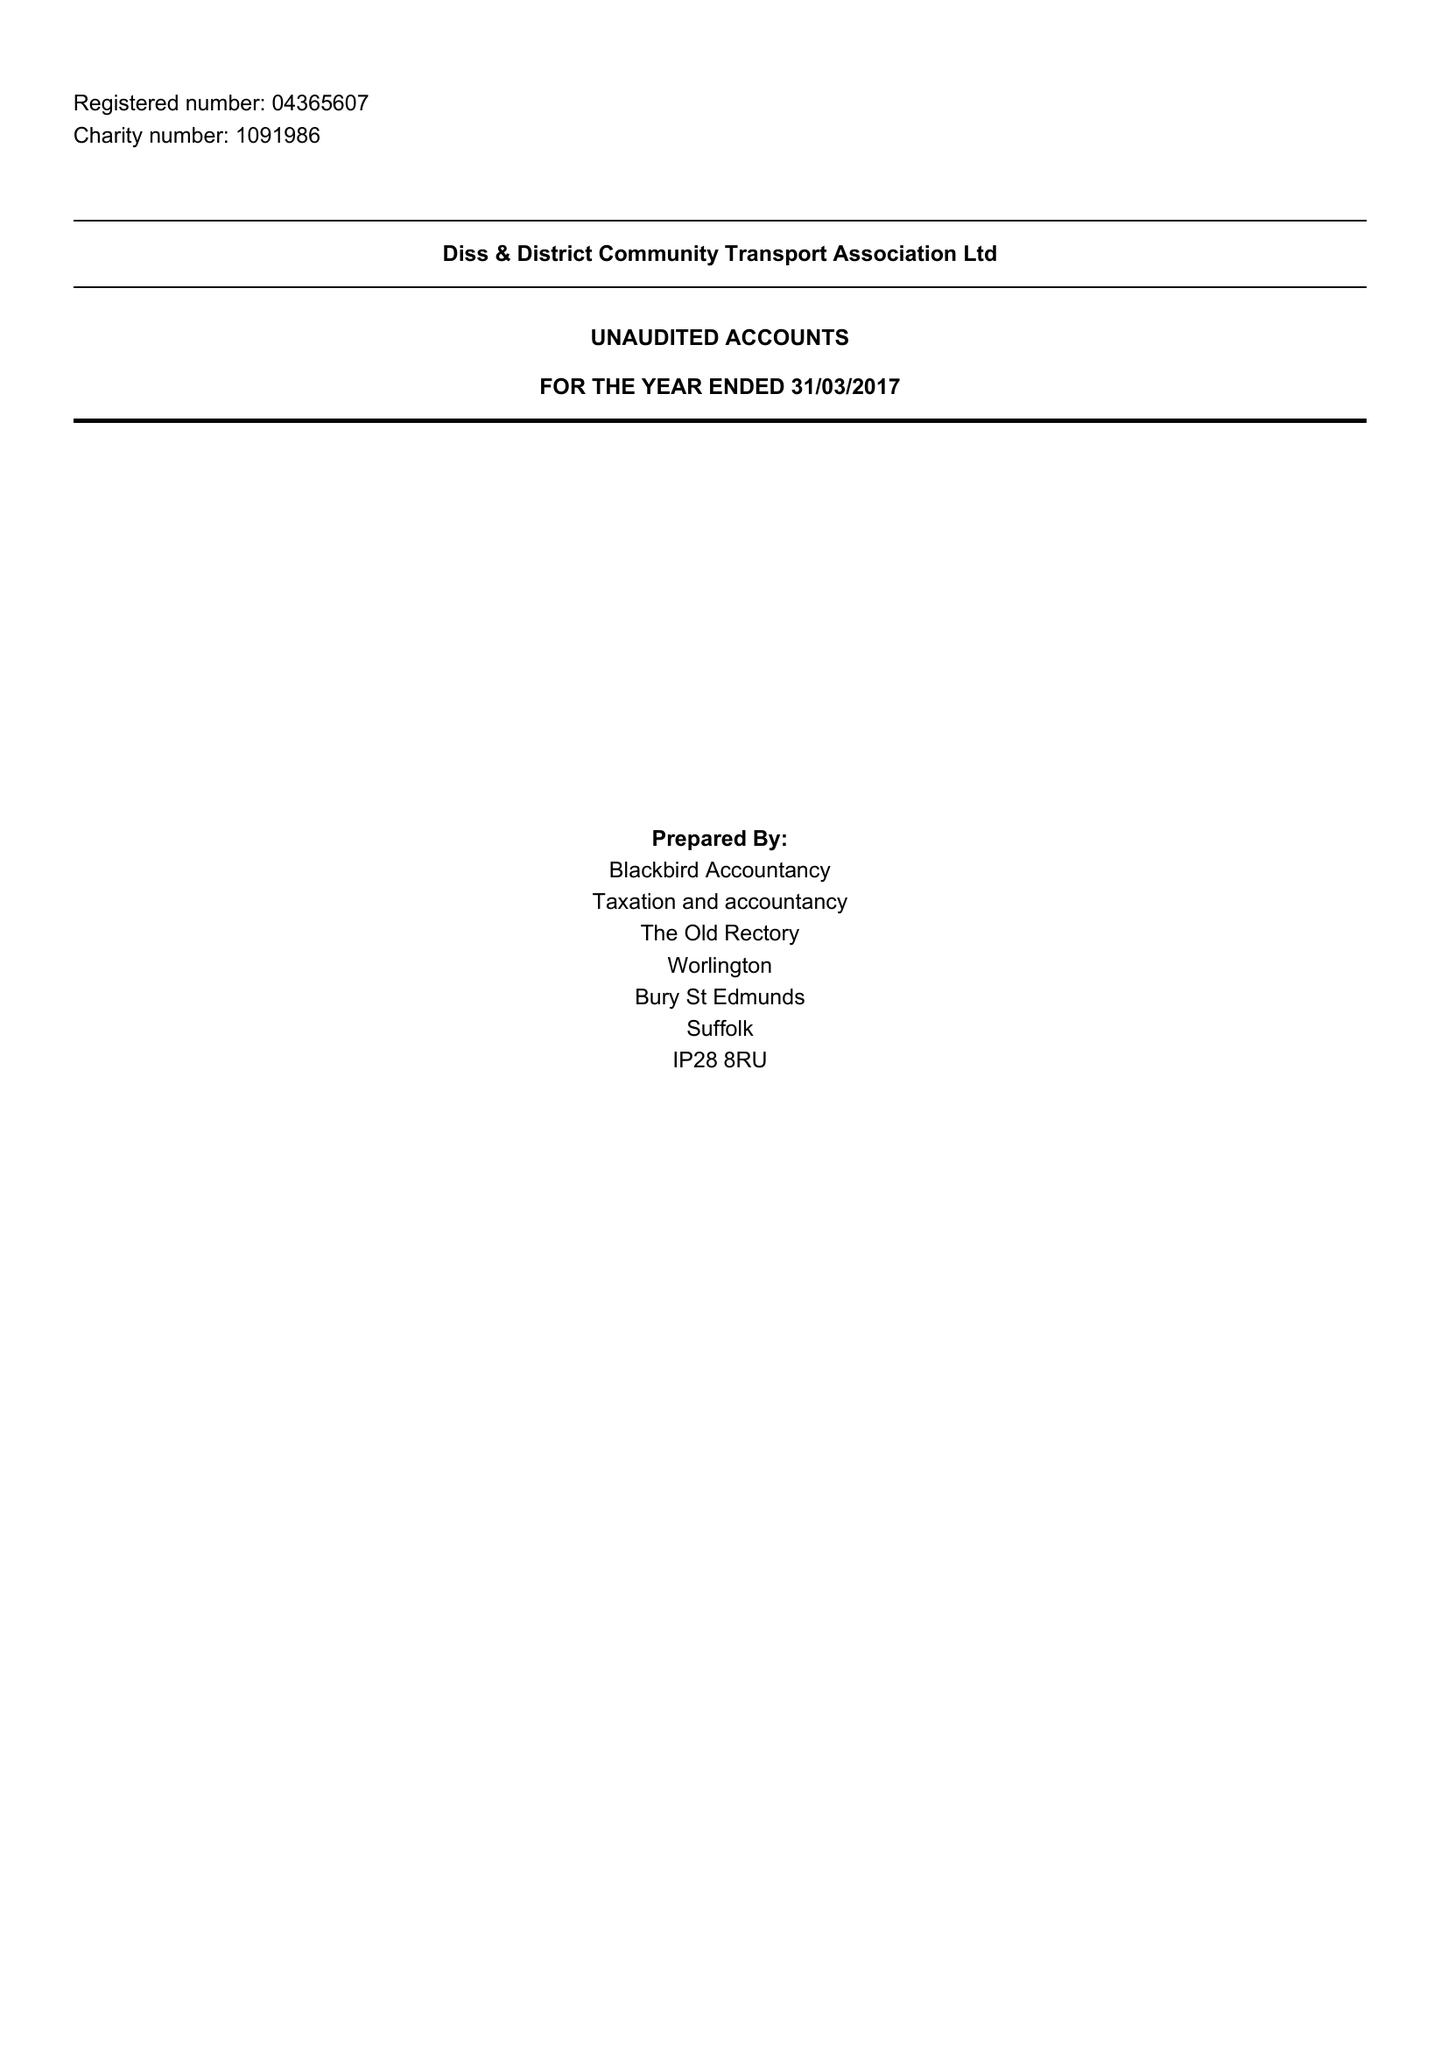What is the value for the report_date?
Answer the question using a single word or phrase. 2017-03-31 